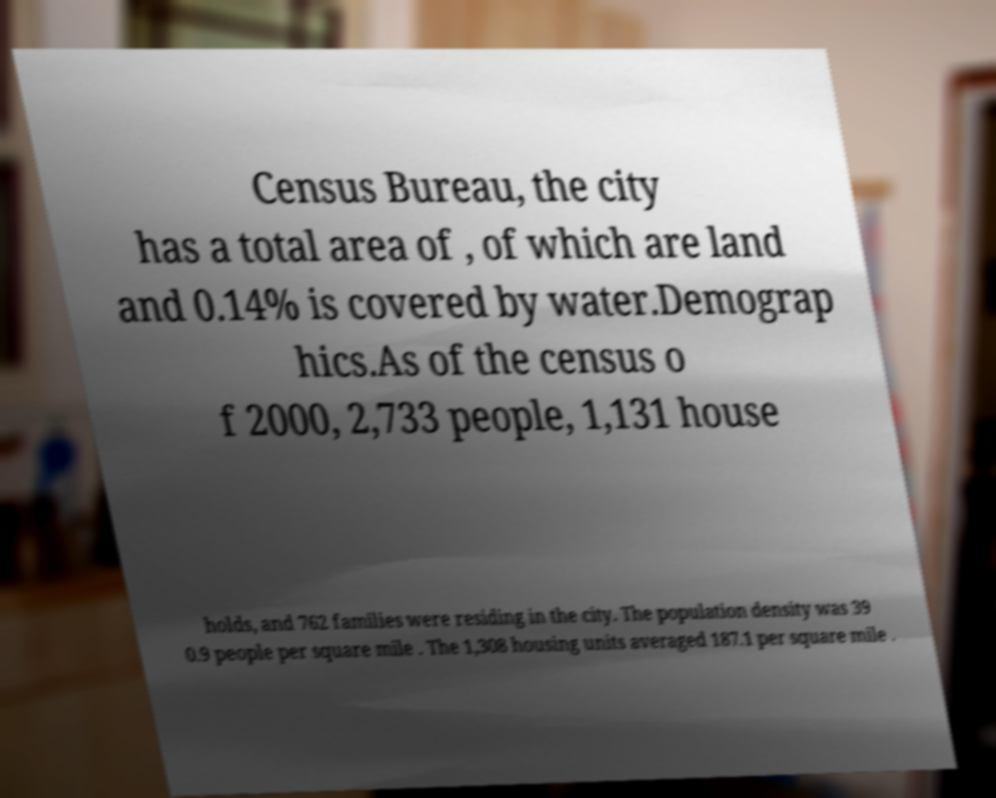Could you extract and type out the text from this image? Census Bureau, the city has a total area of , of which are land and 0.14% is covered by water.Demograp hics.As of the census o f 2000, 2,733 people, 1,131 house holds, and 762 families were residing in the city. The population density was 39 0.9 people per square mile . The 1,308 housing units averaged 187.1 per square mile . 